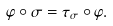Convert formula to latex. <formula><loc_0><loc_0><loc_500><loc_500>\varphi \circ \sigma = \tau _ { \sigma } \circ \varphi .</formula> 